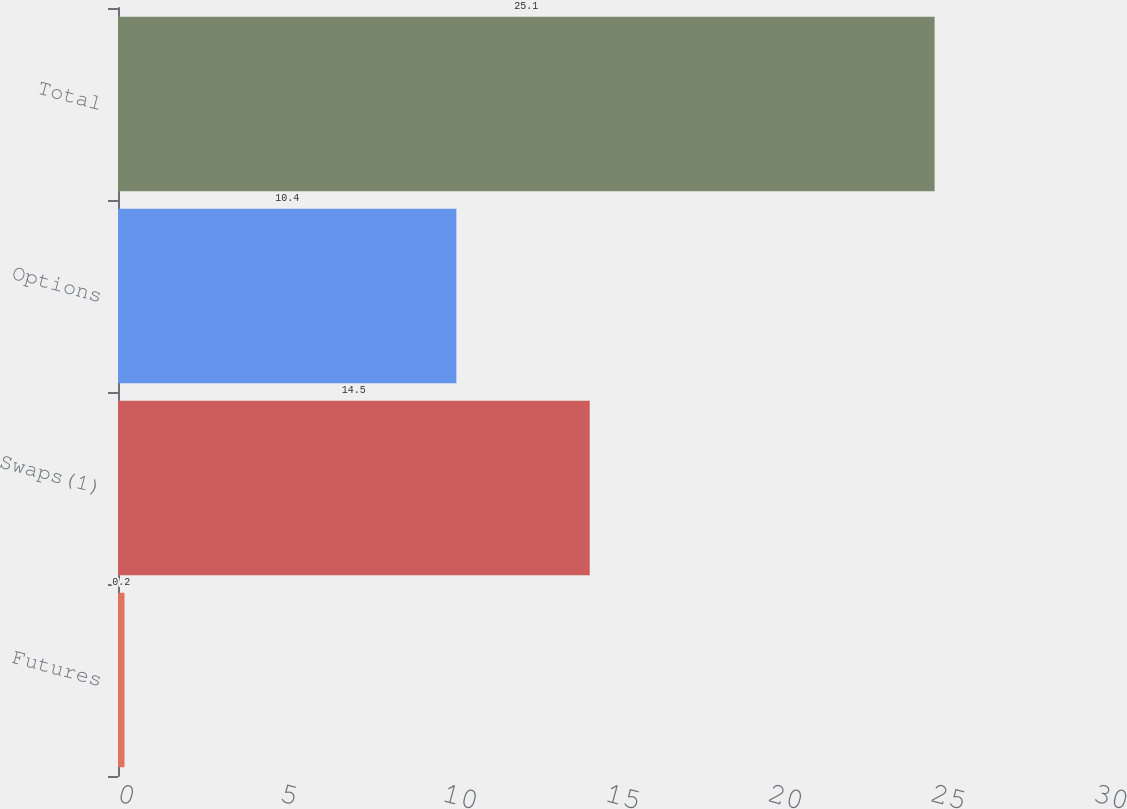<chart> <loc_0><loc_0><loc_500><loc_500><bar_chart><fcel>Futures<fcel>Swaps(1)<fcel>Options<fcel>Total<nl><fcel>0.2<fcel>14.5<fcel>10.4<fcel>25.1<nl></chart> 